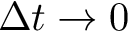Convert formula to latex. <formula><loc_0><loc_0><loc_500><loc_500>\Delta t \rightarrow 0</formula> 